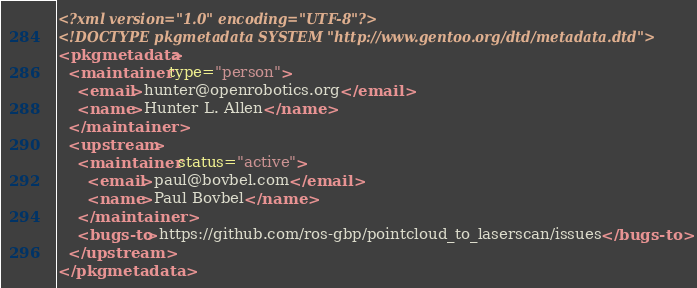<code> <loc_0><loc_0><loc_500><loc_500><_XML_><?xml version="1.0" encoding="UTF-8"?>
<!DOCTYPE pkgmetadata SYSTEM "http://www.gentoo.org/dtd/metadata.dtd">
<pkgmetadata>
  <maintainer type="person">
    <email>hunter@openrobotics.org</email>
    <name>Hunter L. Allen</name>
  </maintainer>
  <upstream>
    <maintainer status="active">
      <email>paul@bovbel.com</email>
      <name>Paul Bovbel</name>
    </maintainer>
    <bugs-to>https://github.com/ros-gbp/pointcloud_to_laserscan/issues</bugs-to>
  </upstream>
</pkgmetadata>
</code> 